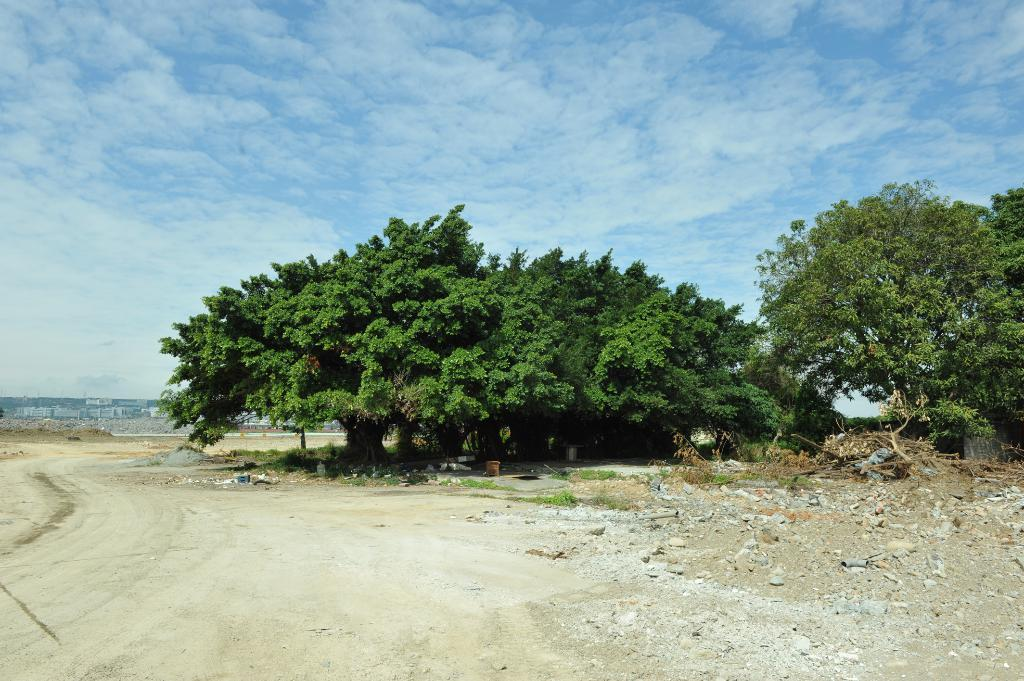What can be seen in the middle of the image? There are trees, stones, and grass in the middle of the image. What is visible in the background of the image? There are houses, poles, and the sky visible in the background of the image. When was the image taken? The image was taken during the day. From where was the image taken? The image was taken from the ground. What type of wine is being served in the mouth of the person in the image? There is no person or wine present in the image; it features trees, stones, grass, houses, poles, and the sky. What is the name of the downtown area visible in the image? There is no downtown area visible in the image; it was taken in a location with trees, stones, grass, houses, poles, and the sky. 